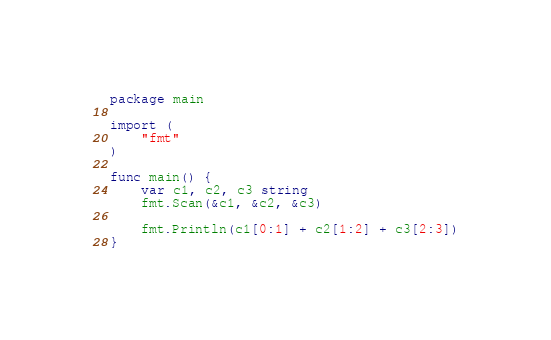<code> <loc_0><loc_0><loc_500><loc_500><_Go_>package main

import (
	"fmt"
)

func main() {
	var c1, c2, c3 string
	fmt.Scan(&c1, &c2, &c3)

	fmt.Println(c1[0:1] + c2[1:2] + c3[2:3])
}
</code> 